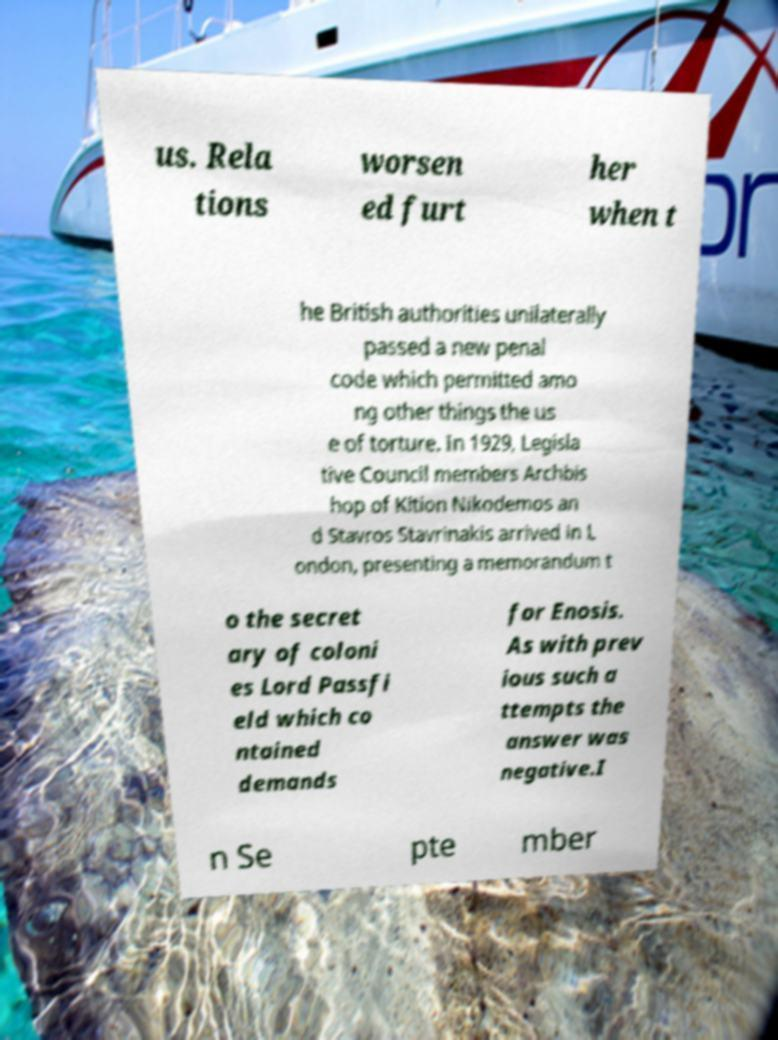Could you assist in decoding the text presented in this image and type it out clearly? us. Rela tions worsen ed furt her when t he British authorities unilaterally passed a new penal code which permitted amo ng other things the us e of torture. In 1929, Legisla tive Council members Archbis hop of Kition Nikodemos an d Stavros Stavrinakis arrived in L ondon, presenting a memorandum t o the secret ary of coloni es Lord Passfi eld which co ntained demands for Enosis. As with prev ious such a ttempts the answer was negative.I n Se pte mber 